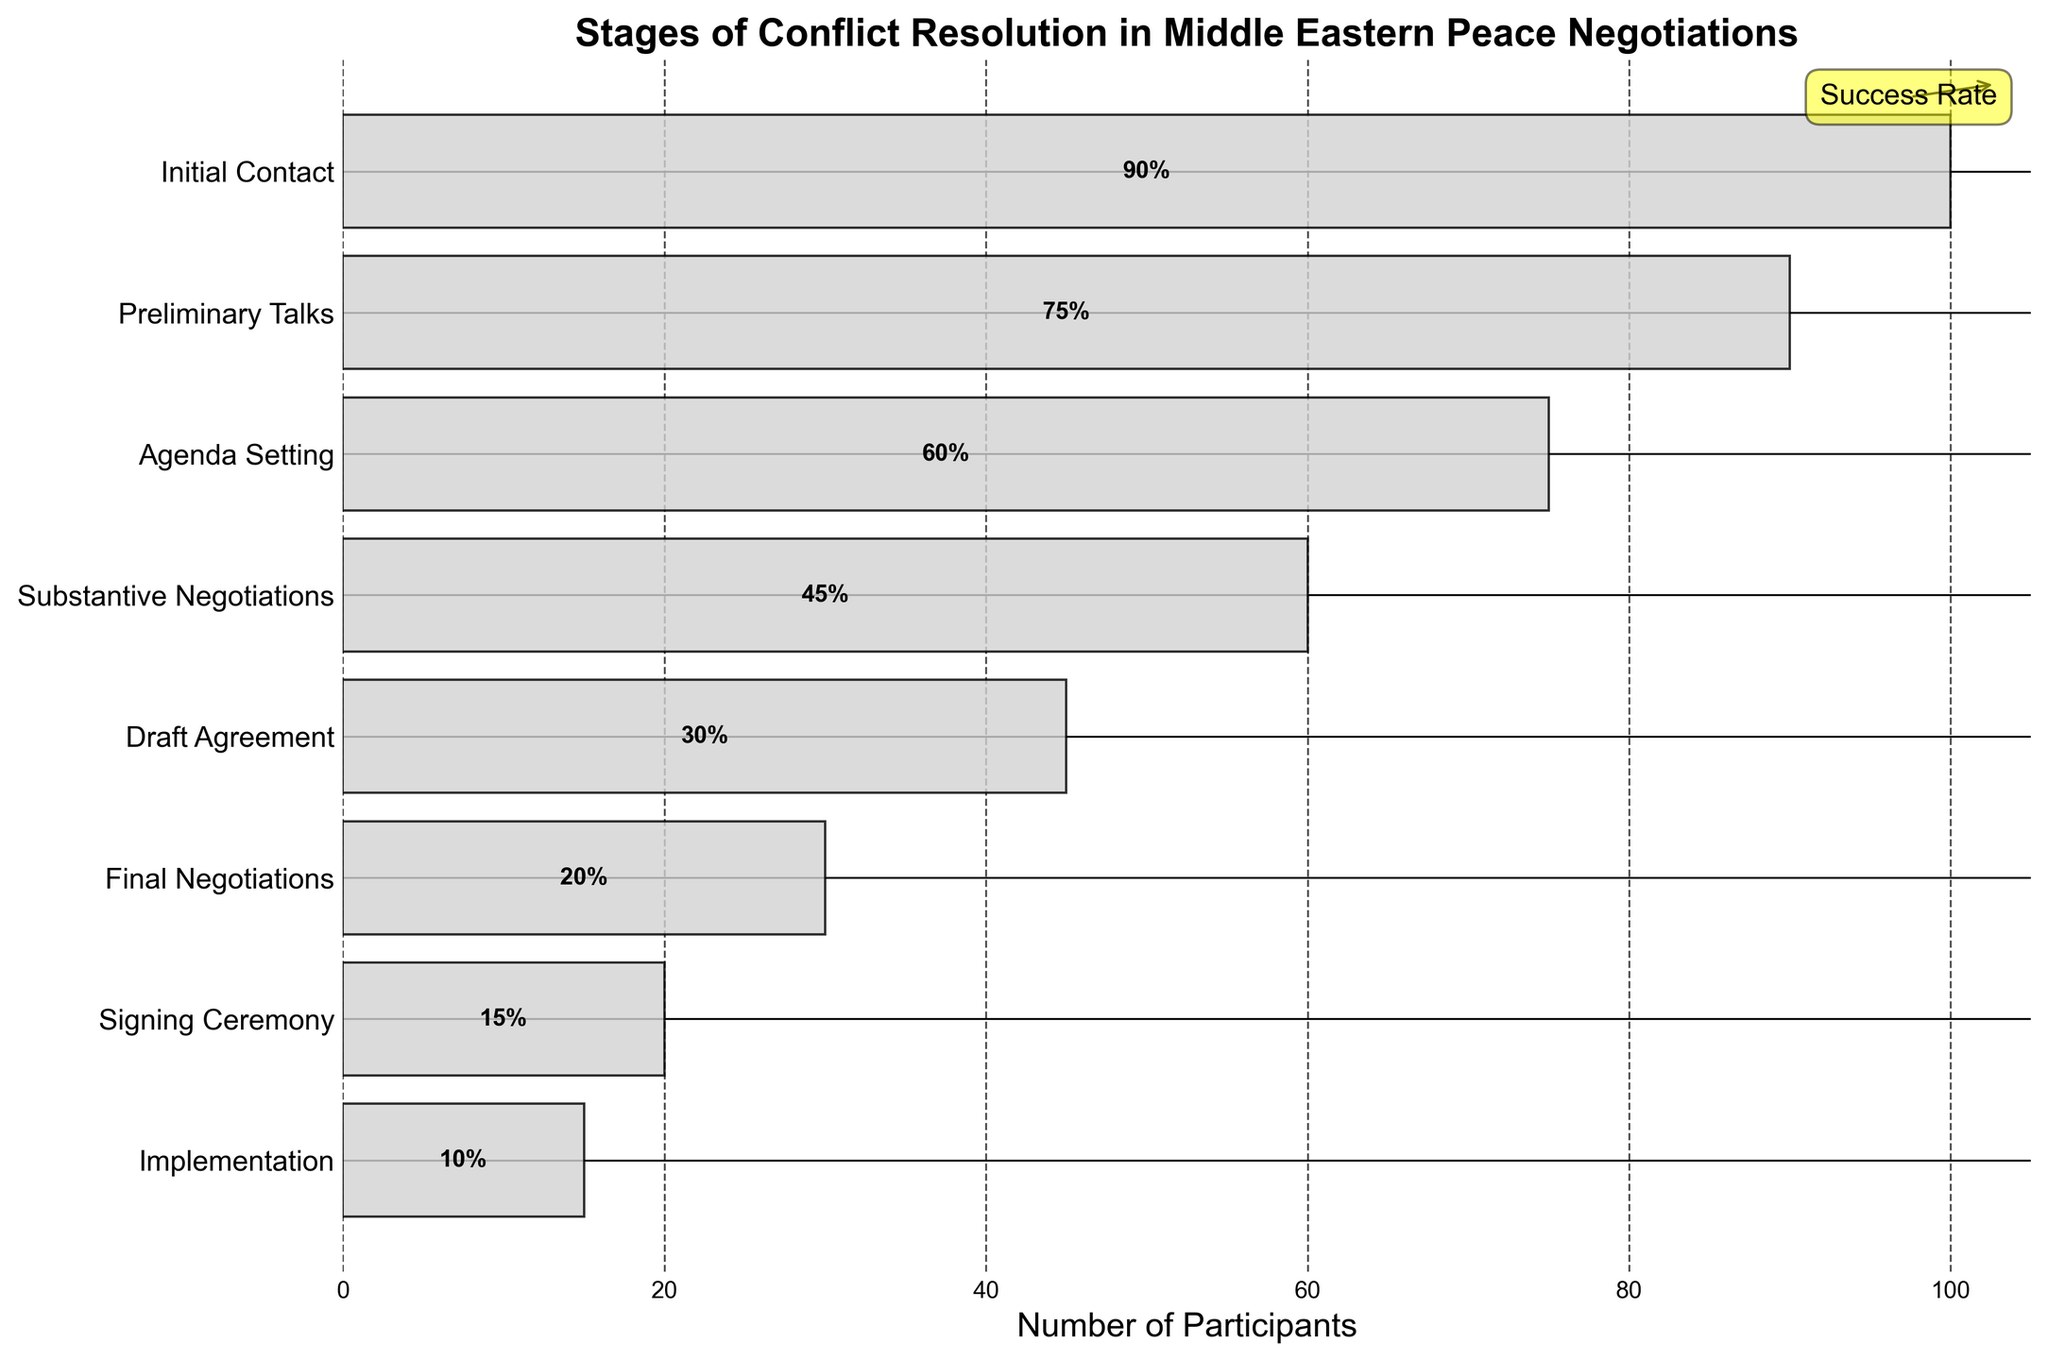What is the title of the funnel chart? The title of a chart is typically displayed at the top and usually provides a concise description of the chart's content.
Answer: Stages of Conflict Resolution in Middle Eastern Peace Negotiations How many stages are there in the conflict resolution process? To find out the number of stages, count the distinct stages listed on the y-axis of the funnel chart.
Answer: 8 Which stage has the highest success rate? Identify the stage with the highest percentage displayed within the bars on the chart. The highest number will indicate the highest success rate.
Answer: Initial Contact How many participants typically reach the Final Negotiations stage? Look at the bar corresponding to the "Final Negotiations" stage and read the number of participants labeled on that bar.
Answer: 30 What is the difference in the number of participants between the Initial Contact and Signing Ceremony stages? Subtract the number of participants in the "Signing Ceremony" stage from the number in the "Initial Contact" stage (100 - 20).
Answer: 80 What is the total success rate from the Initial Contact to the Implementation stage? Add the success rates of each listed stage (90 + 75 + 60 + 45 + 30 + 20 + 15 + 10) to get the total success rate.
Answer: 345% What is the ratio of participants from the Preliminary Talks stage to the Implementation stage? To determine the ratio, divide the number of participants in the "Preliminary Talks" stage by those in the "Implementation" stage (90 / 15).
Answer: 6:1 Which stage sees the largest drop in participants? Calculate the difference in participants between consecutive stages and identify the largest drop. Comparing each drop: (100 - 90), (90 - 75), (75 - 60), (60 - 45), (45 - 30), (30 - 20), (20 - 15), and find the largest value.
Answer: Draft Agreement (45 to 30) At which stage is the success rate 50% or more but less than 60%? Scan the success rates displayed on the bars and identify the stage(s) where the success rate is equal to or more than 50% but less than 60%.
Answer: Agenda Setting What is the average number of participants across all stages? Sum all the participants across each stage (100 + 90 + 75 + 60 + 45 + 30 + 20 + 15) and divide by the number of stages (8).
Answer: 54.375 